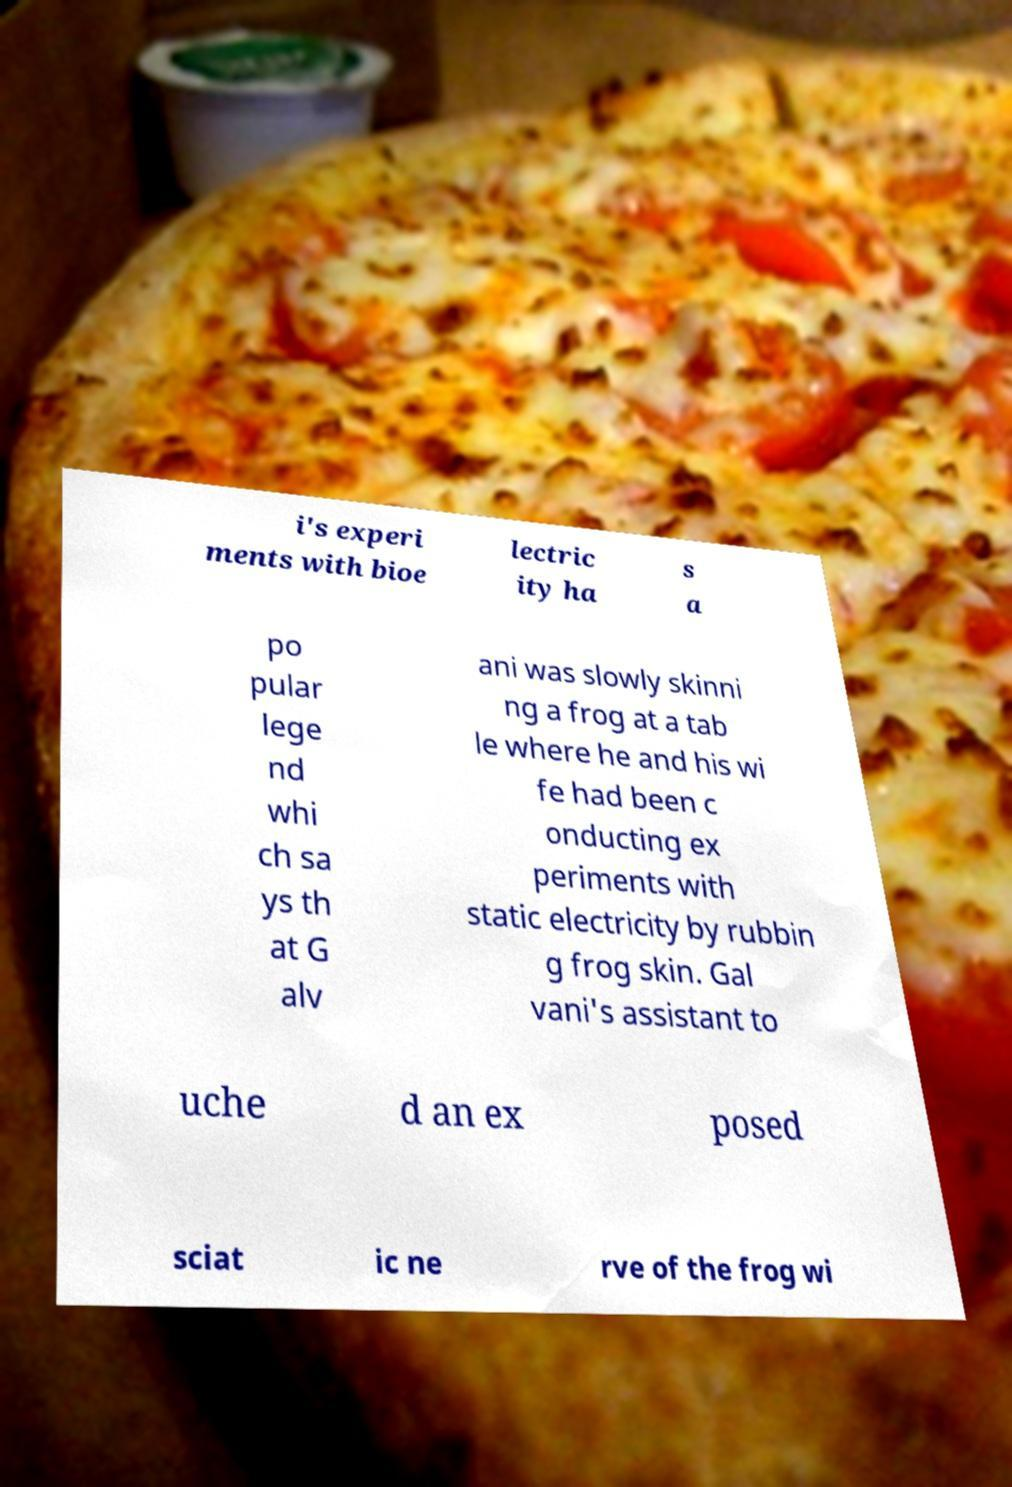Can you accurately transcribe the text from the provided image for me? i's experi ments with bioe lectric ity ha s a po pular lege nd whi ch sa ys th at G alv ani was slowly skinni ng a frog at a tab le where he and his wi fe had been c onducting ex periments with static electricity by rubbin g frog skin. Gal vani's assistant to uche d an ex posed sciat ic ne rve of the frog wi 